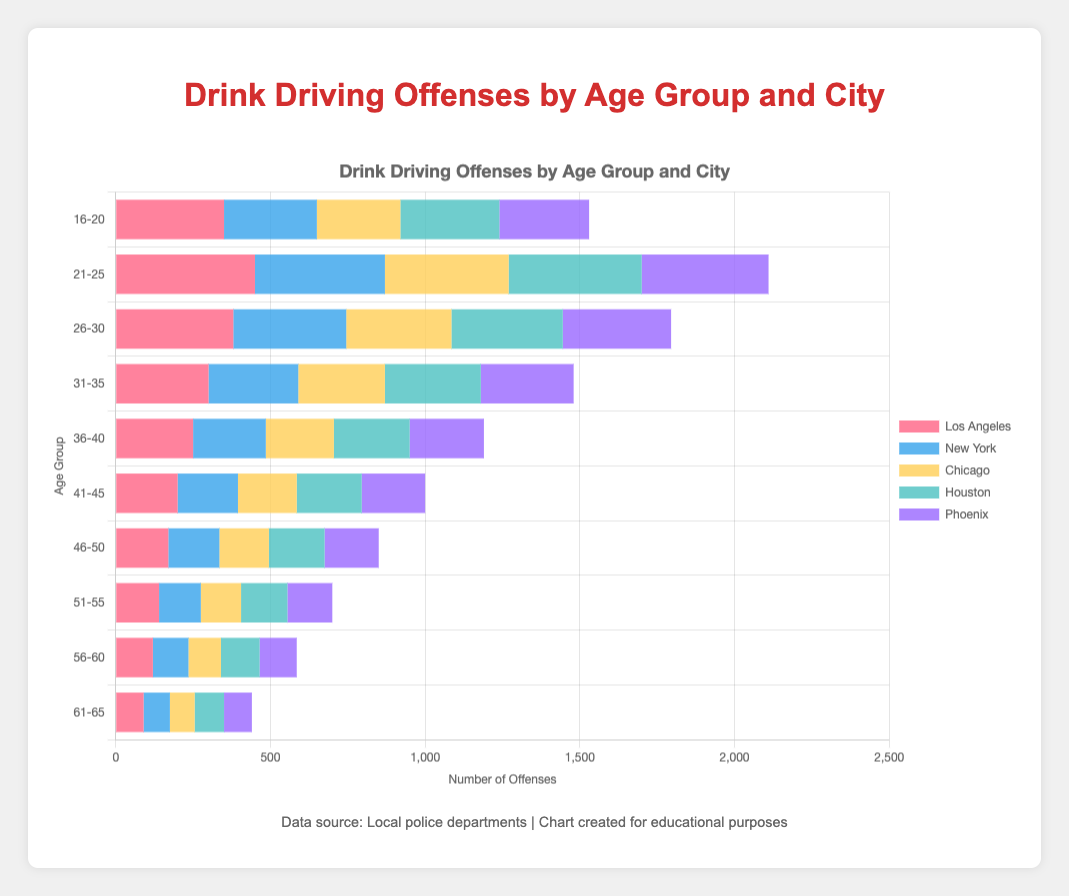What city has the highest number of drink driving offenses for the 21-25 age group? To find the city with the highest number of drink driving offenses for the 21-25 age group, we refer to the bar section corresponding to this age group and compare the lengths of the colored bars. Los Angeles has the longest bar, indicating 450 offenses.
Answer: Los Angeles What is the total number of drink driving offenses for the 36-40 age group across all cities? To compute the total number of offenses for the 36-40 age group, sum up the offenses in each city: 250 (Los Angeles) + 235 (New York) + 220 (Chicago) + 245 (Houston) + 240 (Phoenix) = 1190.
Answer: 1190 Which age group has the fewest drink driving offenses in Phoenix? To identify the age group with the fewest offenses in Phoenix, we compare the heights of the bars corresponding to Phoenix within each age group. The age group 61-65 has the smallest bar, indicating 90 offenses.
Answer: 61-65 How does the number of offenses in Los Angeles for the 41-45 age group compare to the number of offenses in New York for the 41-45 age group? Compare the lengths of the red bar representing Los Angeles and the blue bar representing New York for the 41-45 age group. Los Angeles has 200 offenses, and New York has 195 offenses. Los Angeles has slightly more offenses than New York for this age group.
Answer: Los Angeles has more What is the average number of offenses for the 26-30 age group across all cities? To find the average, first sum up the offenses: 380 (Los Angeles) + 365 (New York) + 340 (Chicago) + 360 (Houston) + 350 (Phoenix) = 1795. Then, divide by the number of cities: 1795 / 5 = 359.
Answer: 359 Considering the 51-55 age group, by how much do the total offenses in Los Angeles exceed those in Chicago? Calculate the difference in the number of offenses: Los Angeles has 140 offenses, and Chicago has 130. The excess is 140 - 130 = 10.
Answer: 10 What is the most visually distinct color in the chart for New York's data and which age group does it represent? Identify the color used to represent New York in the chart. The most visually distinct color for New York data is blue, and it spans across all age groups consistently, not tied to one specific age group.
Answer: Blue Which age group shows the steepest decline in drink driving offenses when transitioning from the younger age group to the next age group? Observe the decreases in offenses between consecutive age groups. The decline from 21-25 (highest) to 26-30 is notable but further check is needed. The steepest decline is from 16-20 to 21-25: for instance, Los Angeles goes from 350 to 450 (-100), similarly large reductions across other cities.
Answer: 21-25 to 26-30 How many offenses are there on average in Houston for the age groups 51-55 and 56-60? First, sum the offenses for these age groups: 150 (51-55) + 125 (56-60) = 275. Then, divide by the number of age groups: 275 / 2 = 137.5.
Answer: 137.5 